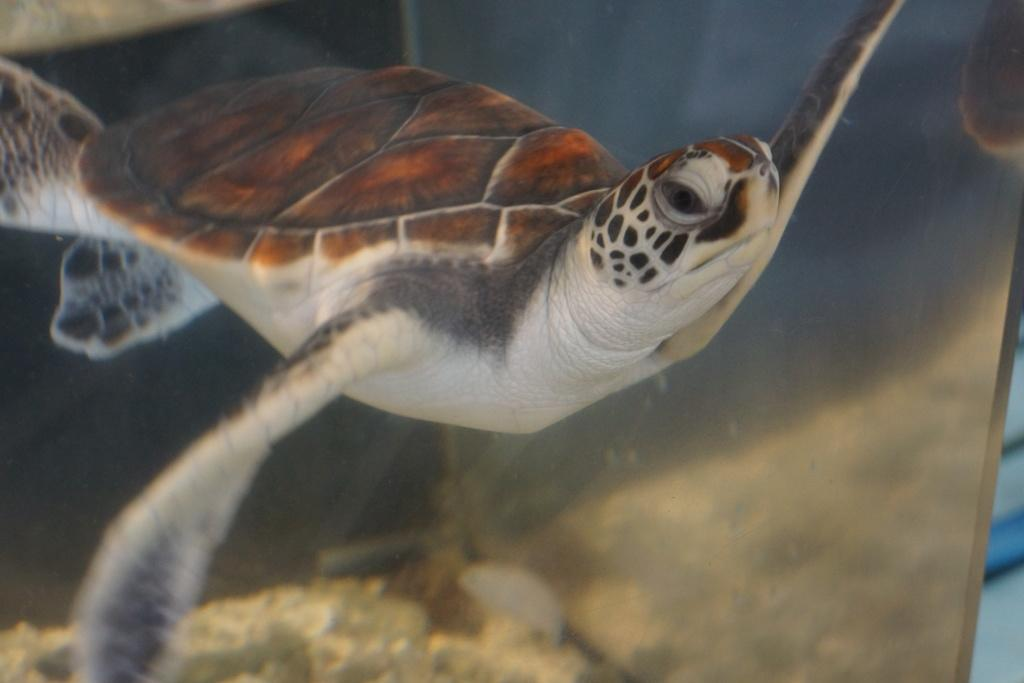What type of animal is in the image? There is a tortoise in the image. Where is the tortoise located? The tortoise is in water. What type of clouds can be seen above the houses in the image? There are no houses or clouds present in the image; it features a tortoise in water. 